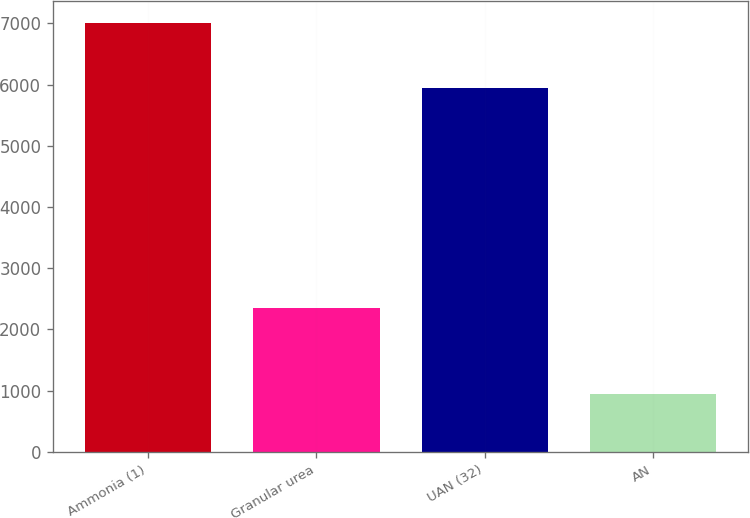<chart> <loc_0><loc_0><loc_500><loc_500><bar_chart><fcel>Ammonia (1)<fcel>Granular urea<fcel>UAN (32)<fcel>AN<nl><fcel>7011<fcel>2347<fcel>5939<fcel>950<nl></chart> 